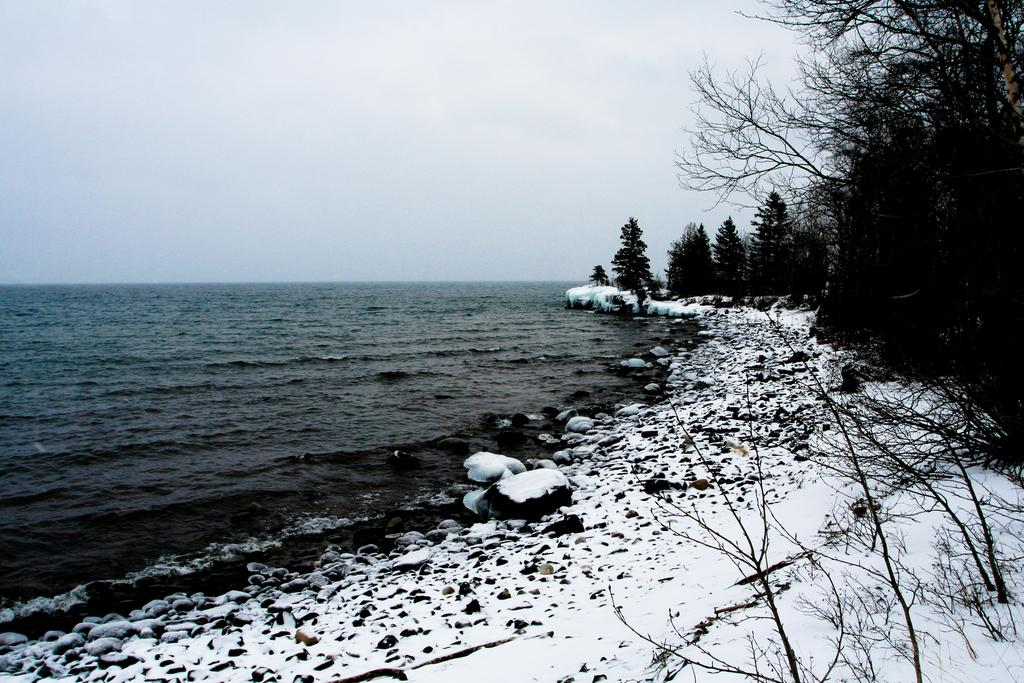What is the primary element in the image? There is water in the image. What other objects or features can be seen in the image? There are rocks, snow, trees on the snow, and the sky visible in the background. How does the snow interact with the other elements in the image? The snow is present on the ground and has trees growing on it. What type of banana can be seen growing on the trees in the image? There are no bananas present in the image; it features trees growing on snow. Can you tell me what time it is by looking at the watch in the image? There is no watch present in the image. 